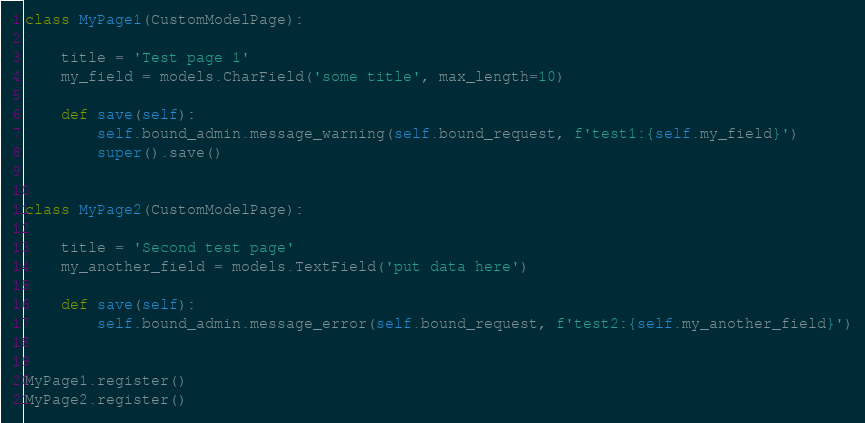<code> <loc_0><loc_0><loc_500><loc_500><_Python_>

class MyPage1(CustomModelPage):

    title = 'Test page 1'
    my_field = models.CharField('some title', max_length=10)

    def save(self):
        self.bound_admin.message_warning(self.bound_request, f'test1:{self.my_field}')
        super().save()


class MyPage2(CustomModelPage):

    title = 'Second test page'
    my_another_field = models.TextField('put data here')

    def save(self):
        self.bound_admin.message_error(self.bound_request, f'test2:{self.my_another_field}')


MyPage1.register()
MyPage2.register()
</code> 